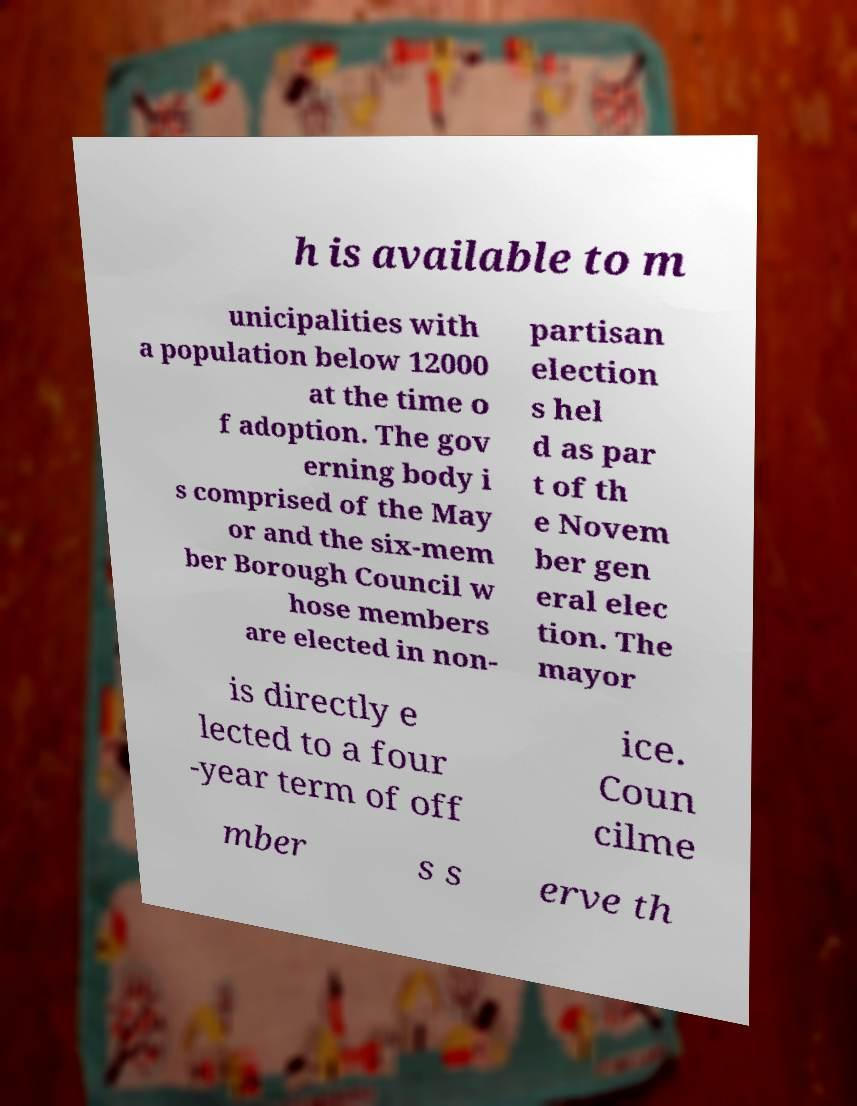Could you extract and type out the text from this image? h is available to m unicipalities with a population below 12000 at the time o f adoption. The gov erning body i s comprised of the May or and the six-mem ber Borough Council w hose members are elected in non- partisan election s hel d as par t of th e Novem ber gen eral elec tion. The mayor is directly e lected to a four -year term of off ice. Coun cilme mber s s erve th 